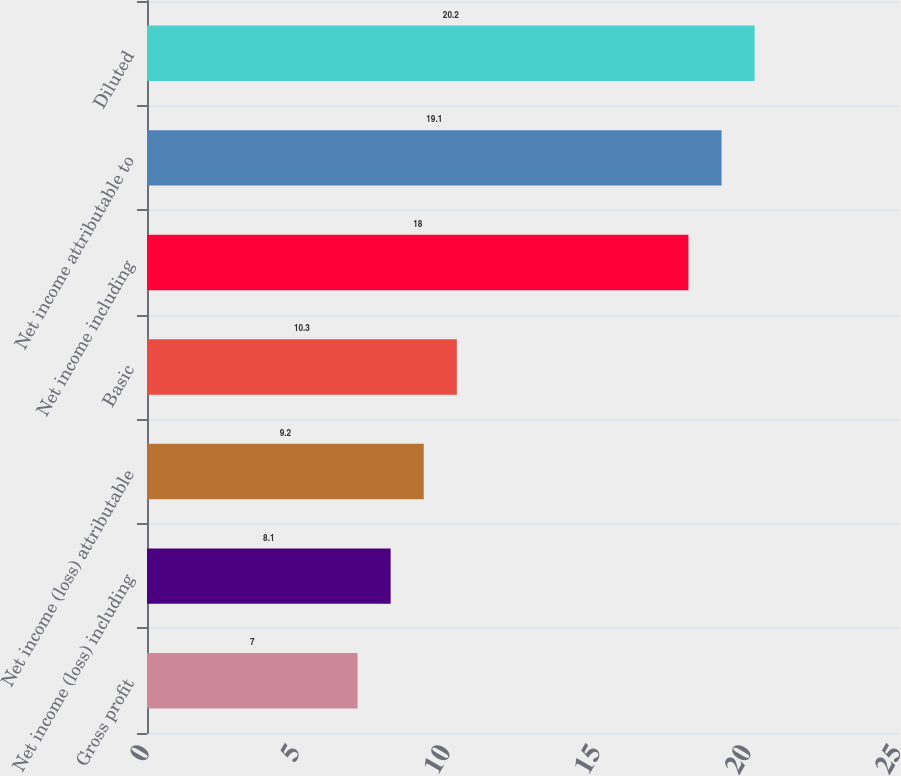Convert chart. <chart><loc_0><loc_0><loc_500><loc_500><bar_chart><fcel>Gross profit<fcel>Net income (loss) including<fcel>Net income (loss) attributable<fcel>Basic<fcel>Net income including<fcel>Net income attributable to<fcel>Diluted<nl><fcel>7<fcel>8.1<fcel>9.2<fcel>10.3<fcel>18<fcel>19.1<fcel>20.2<nl></chart> 